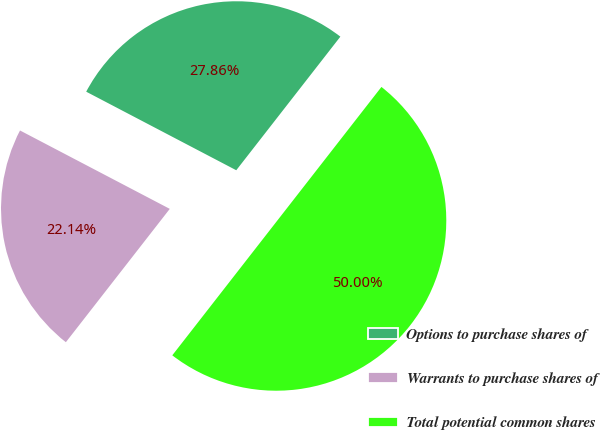Convert chart to OTSL. <chart><loc_0><loc_0><loc_500><loc_500><pie_chart><fcel>Options to purchase shares of<fcel>Warrants to purchase shares of<fcel>Total potential common shares<nl><fcel>27.86%<fcel>22.14%<fcel>50.0%<nl></chart> 